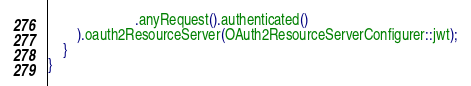<code> <loc_0><loc_0><loc_500><loc_500><_Java_>                        .anyRequest().authenticated()
        ).oauth2ResourceServer(OAuth2ResourceServerConfigurer::jwt);
    }
}
</code> 